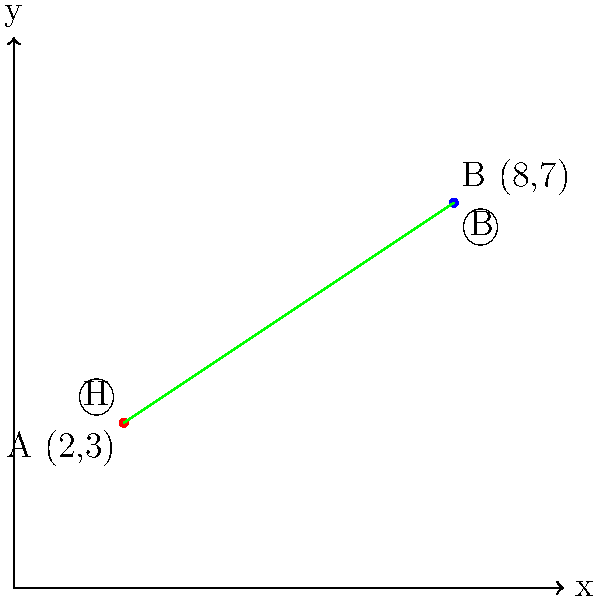In an ancient cave painting, two animal motifs are discovered: a horse (H) and a bison (B). Their positions on a coordinate grid are represented as H(2,3) and B(8,7). Calculate the slope of the line connecting these two motifs. What does this slope suggest about the relative positioning of these animals in the cave art composition? To determine the slope of the line connecting the two animal motifs, we'll follow these steps:

1) Recall the slope formula: $m = \frac{y_2 - y_1}{x_2 - x_1}$

2) Identify the coordinates:
   Horse (H): $(x_1, y_1) = (2, 3)$
   Bison (B): $(x_2, y_2) = (8, 7)$

3) Substitute these values into the slope formula:

   $m = \frac{7 - 3}{8 - 2} = \frac{4}{6}$

4) Simplify the fraction:

   $m = \frac{2}{3} \approx 0.667$

5) Interpret the result:
   The positive slope indicates that as we move from the horse to the bison in the composition, there is an upward trend. The slope of $\frac{2}{3}$ suggests a moderate incline, implying that the bison is positioned slightly higher and to the right of the horse in the cave painting.

This arrangement could suggest a hierarchical or narrative element in the composition, with the bison potentially being given a more prominent or elevated position compared to the horse. Alternatively, it might represent a natural scene where the animals are on different levels of terrain.
Answer: $\frac{2}{3}$ 